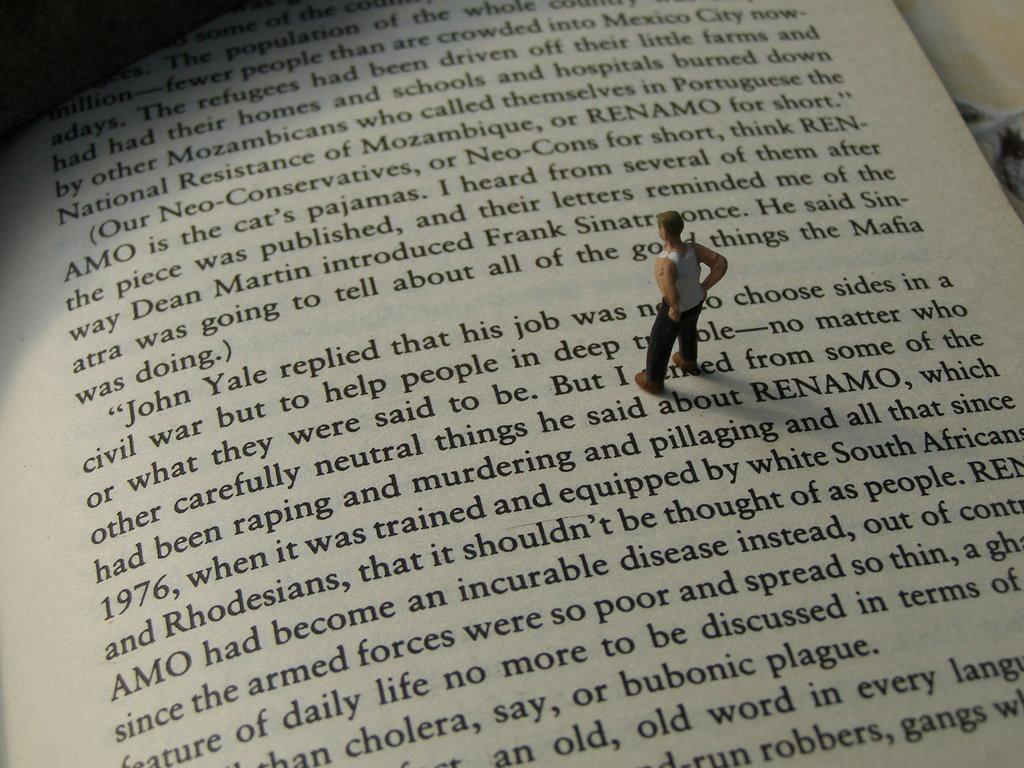What is written on the paper in the image? The provided facts do not specify the content of the text on the paper. What type of toy is present in the image? There is a toy of a person in the image. What type of teeth can be seen in the image? There are no teeth visible in the image. How does the toy need to be sorted in the image? The provided facts do not mention any sorting or adjustment of the toy. 